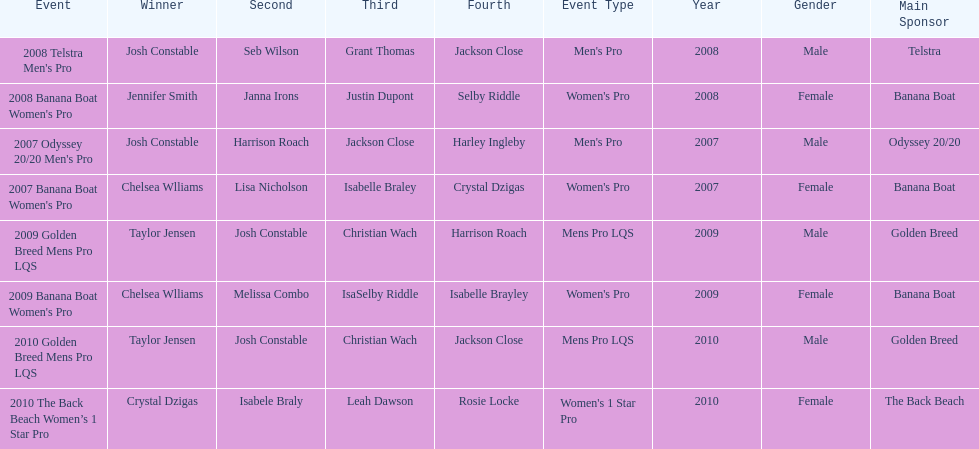In which two events did chelsea williams secure an equal rank? 2007 Banana Boat Women's Pro, 2009 Banana Boat Women's Pro. Give me the full table as a dictionary. {'header': ['Event', 'Winner', 'Second', 'Third', 'Fourth', 'Event Type', 'Year', 'Gender', 'Main Sponsor'], 'rows': [["2008 Telstra Men's Pro", 'Josh Constable', 'Seb Wilson', 'Grant Thomas', 'Jackson Close', "Men's Pro", '2008', 'Male', 'Telstra'], ["2008 Banana Boat Women's Pro", 'Jennifer Smith', 'Janna Irons', 'Justin Dupont', 'Selby Riddle', "Women's Pro", '2008', 'Female', 'Banana Boat'], ["2007 Odyssey 20/20 Men's Pro", 'Josh Constable', 'Harrison Roach', 'Jackson Close', 'Harley Ingleby', "Men's Pro", '2007', 'Male', 'Odyssey 20/20'], ["2007 Banana Boat Women's Pro", 'Chelsea Wlliams', 'Lisa Nicholson', 'Isabelle Braley', 'Crystal Dzigas', "Women's Pro", '2007', 'Female', 'Banana Boat'], ['2009 Golden Breed Mens Pro LQS', 'Taylor Jensen', 'Josh Constable', 'Christian Wach', 'Harrison Roach', 'Mens Pro LQS', '2009', 'Male', 'Golden Breed'], ["2009 Banana Boat Women's Pro", 'Chelsea Wlliams', 'Melissa Combo', 'IsaSelby Riddle', 'Isabelle Brayley', "Women's Pro", '2009', 'Female', 'Banana Boat'], ['2010 Golden Breed Mens Pro LQS', 'Taylor Jensen', 'Josh Constable', 'Christian Wach', 'Jackson Close', 'Mens Pro LQS', '2010', 'Male', 'Golden Breed'], ['2010 The Back Beach Women’s 1 Star Pro', 'Crystal Dzigas', 'Isabele Braly', 'Leah Dawson', 'Rosie Locke', "Women's 1 Star Pro", '2010', 'Female', 'The Back Beach']]} 